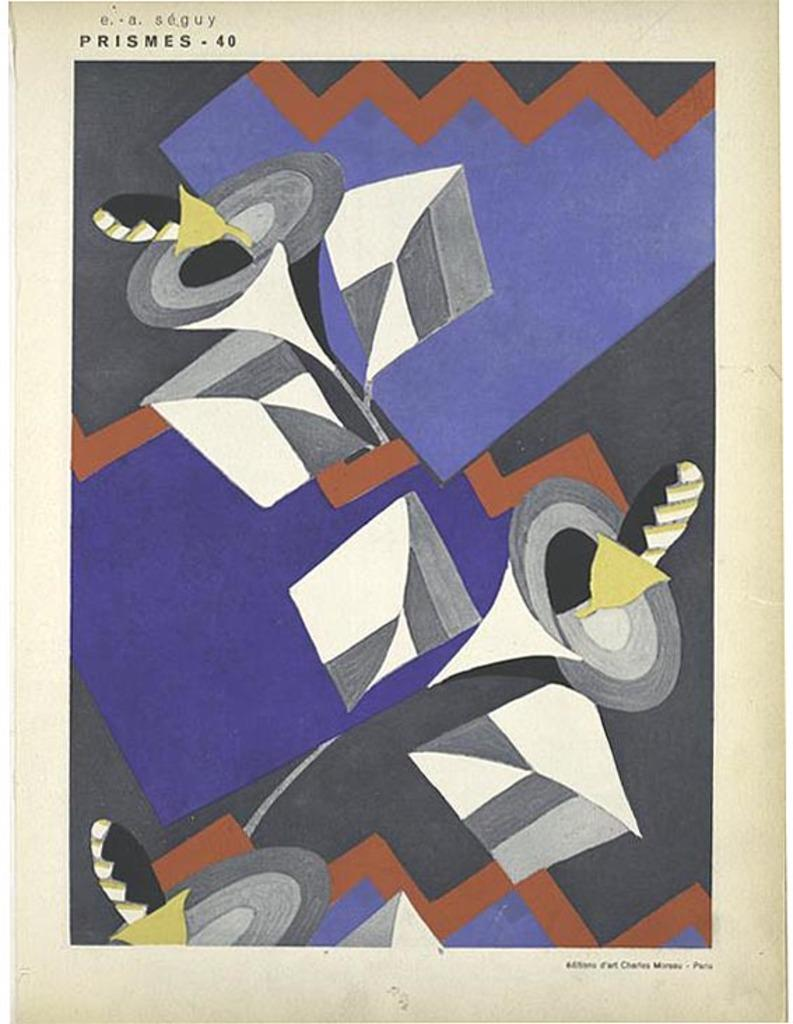What is the main subject of the image? The image contains an art piece. Can you describe the colors used in the art piece? The colors in the art piece include blue, white, black, yellow, and grey. Are there any words or letters in the art piece? Yes, there is writing present in the art piece. Can you see a fan in the art piece? There is no fan present in the art piece; it only contains colors, writing, and possibly other artistic elements. 